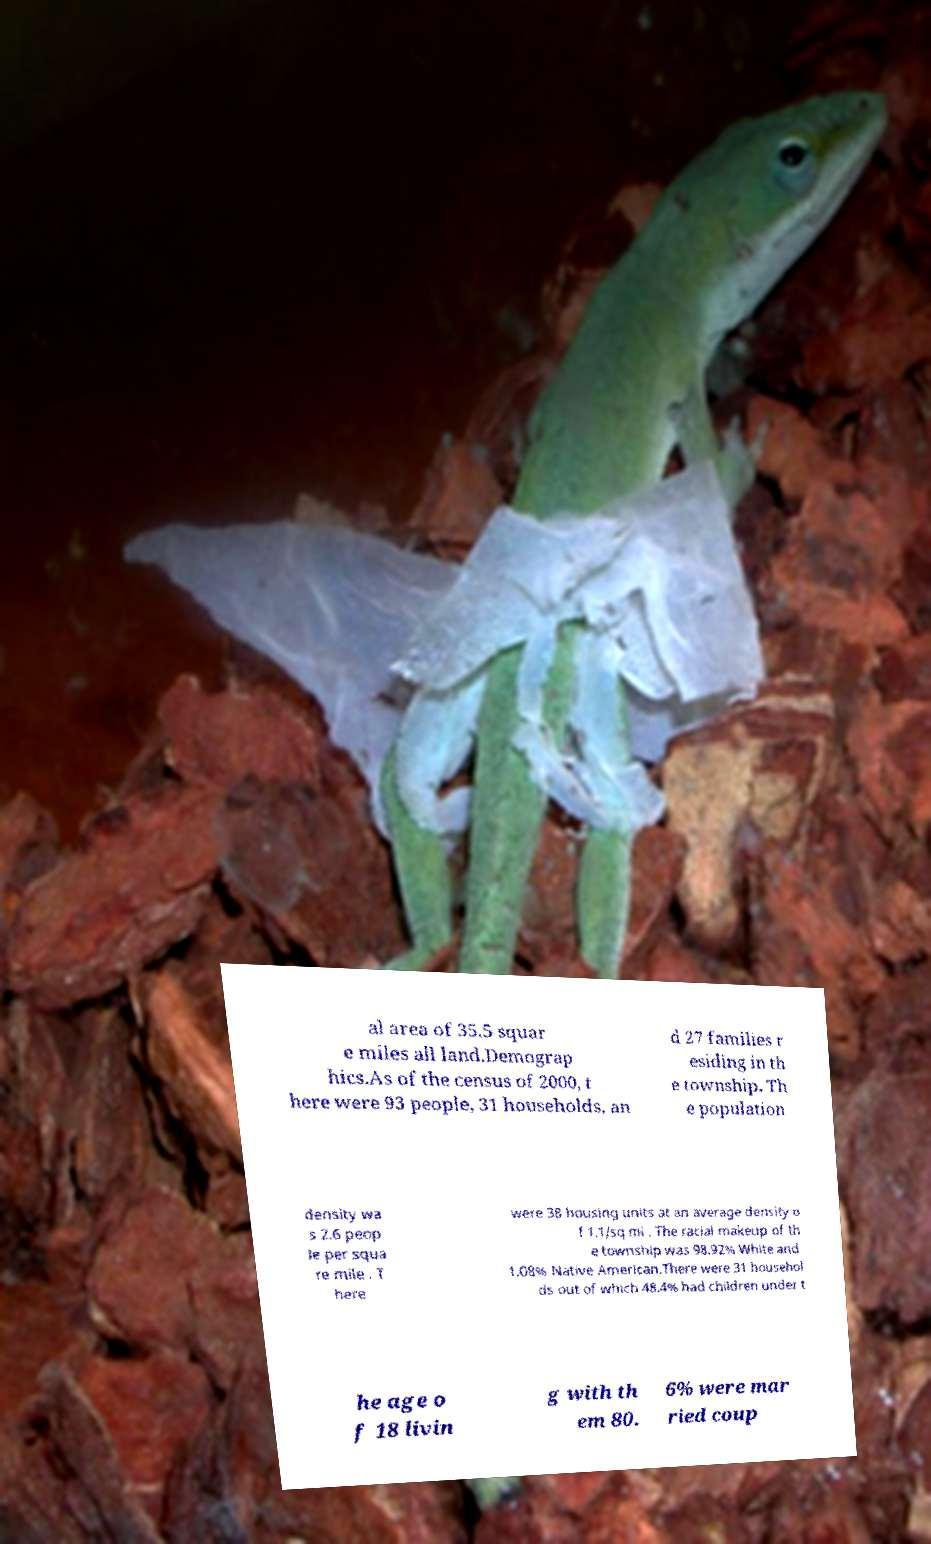Could you extract and type out the text from this image? al area of 35.5 squar e miles all land.Demograp hics.As of the census of 2000, t here were 93 people, 31 households, an d 27 families r esiding in th e township. Th e population density wa s 2.6 peop le per squa re mile . T here were 38 housing units at an average density o f 1.1/sq mi . The racial makeup of th e township was 98.92% White and 1.08% Native American.There were 31 househol ds out of which 48.4% had children under t he age o f 18 livin g with th em 80. 6% were mar ried coup 